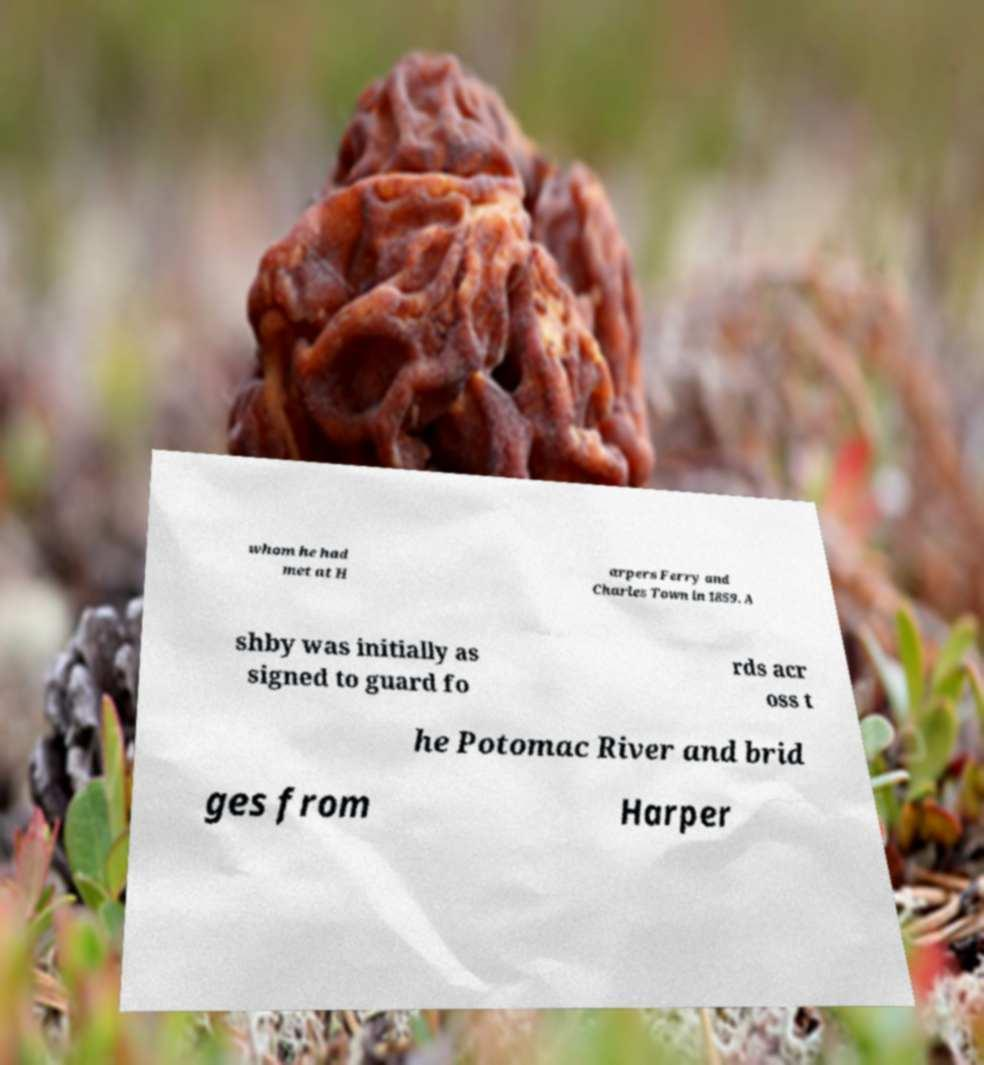Can you read and provide the text displayed in the image?This photo seems to have some interesting text. Can you extract and type it out for me? whom he had met at H arpers Ferry and Charles Town in 1859. A shby was initially as signed to guard fo rds acr oss t he Potomac River and brid ges from Harper 